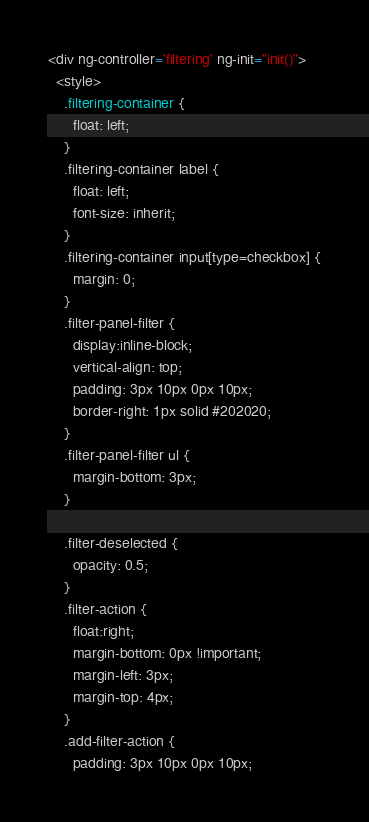<code> <loc_0><loc_0><loc_500><loc_500><_HTML_><div ng-controller='filtering' ng-init="init()">
  <style>
    .filtering-container {
      float: left;
    }
    .filtering-container label {
      float: left;
      font-size: inherit;
    }
    .filtering-container input[type=checkbox] {
      margin: 0;
    }
    .filter-panel-filter {
      display:inline-block;
      vertical-align: top;
      padding: 3px 10px 0px 10px;
      border-right: 1px solid #202020;
    }
    .filter-panel-filter ul {
      margin-bottom: 3px;
    }

    .filter-deselected {
      opacity: 0.5;
    }
    .filter-action {
      float:right;
      margin-bottom: 0px !important;
      margin-left: 3px;
      margin-top: 4px;
    }
    .add-filter-action {
      padding: 3px 10px 0px 10px;</code> 